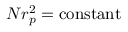Convert formula to latex. <formula><loc_0><loc_0><loc_500><loc_500>N r _ { p } ^ { 2 } = c o n s t a n t</formula> 